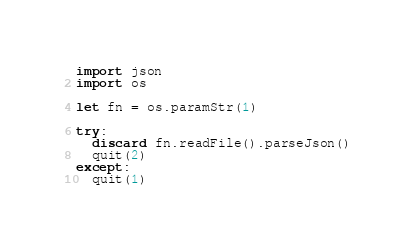<code> <loc_0><loc_0><loc_500><loc_500><_Nim_>
import json
import os

let fn = os.paramStr(1)

try:
  discard fn.readFile().parseJson()
  quit(2)
except:
  quit(1)
</code> 